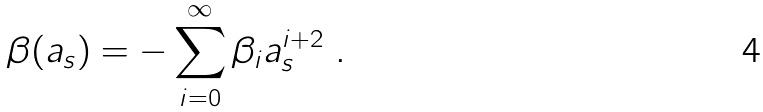<formula> <loc_0><loc_0><loc_500><loc_500>\beta ( a _ { s } ) = - \sum _ { i = 0 } ^ { \infty } \beta _ { i } a _ { s } ^ { i + 2 } \ .</formula> 